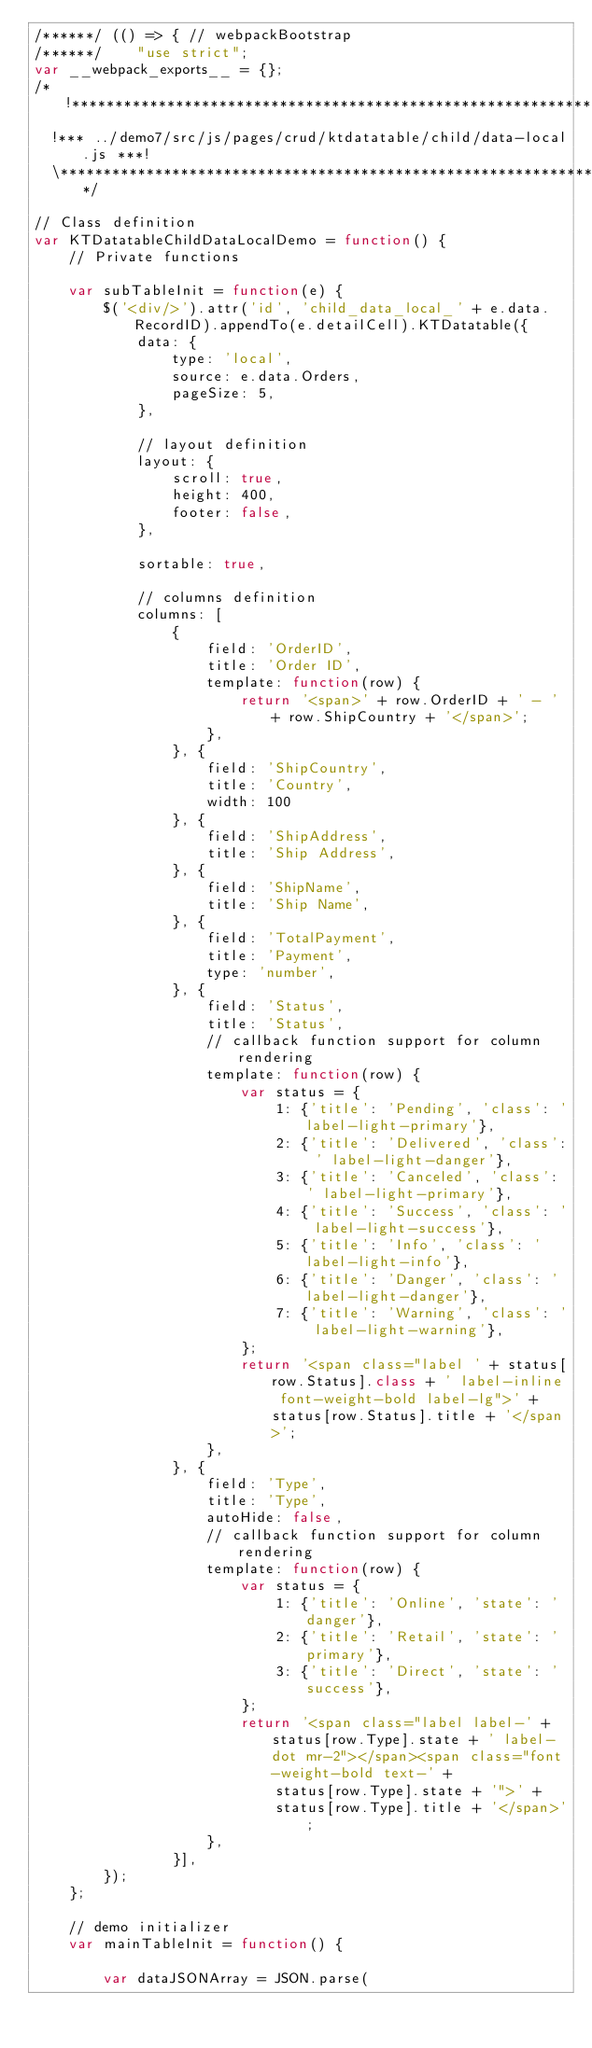<code> <loc_0><loc_0><loc_500><loc_500><_JavaScript_>/******/ (() => { // webpackBootstrap
/******/ 	"use strict";
var __webpack_exports__ = {};
/*!******************************************************************!*\
  !*** ../demo7/src/js/pages/crud/ktdatatable/child/data-local.js ***!
  \******************************************************************/

// Class definition
var KTDatatableChildDataLocalDemo = function() {
	// Private functions

	var subTableInit = function(e) {
		$('<div/>').attr('id', 'child_data_local_' + e.data.RecordID).appendTo(e.detailCell).KTDatatable({
			data: {
				type: 'local',
				source: e.data.Orders,
				pageSize: 5,
			},

			// layout definition
			layout: {
				scroll: true,
				height: 400,
				footer: false,
			},

			sortable: true,

			// columns definition
			columns: [
				{
					field: 'OrderID',
					title: 'Order ID',
					template: function(row) {
						return '<span>' + row.OrderID + ' - ' + row.ShipCountry + '</span>';
					},
				}, {
					field: 'ShipCountry',
					title: 'Country',
					width: 100
				}, {
					field: 'ShipAddress',
					title: 'Ship Address',
				}, {
					field: 'ShipName',
					title: 'Ship Name',
				}, {
					field: 'TotalPayment',
					title: 'Payment',
					type: 'number',
				}, {
					field: 'Status',
					title: 'Status',
					// callback function support for column rendering
					template: function(row) {
						var status = {
							1: {'title': 'Pending', 'class': 'label-light-primary'},
							2: {'title': 'Delivered', 'class': ' label-light-danger'},
							3: {'title': 'Canceled', 'class': ' label-light-primary'},
							4: {'title': 'Success', 'class': ' label-light-success'},
							5: {'title': 'Info', 'class': ' label-light-info'},
							6: {'title': 'Danger', 'class': ' label-light-danger'},
							7: {'title': 'Warning', 'class': ' label-light-warning'},
						};
						return '<span class="label ' + status[row.Status].class + ' label-inline font-weight-bold label-lg">' + status[row.Status].title + '</span>';
					},
				}, {
					field: 'Type',
					title: 'Type',
					autoHide: false,
					// callback function support for column rendering
					template: function(row) {
						var status = {
							1: {'title': 'Online', 'state': 'danger'},
							2: {'title': 'Retail', 'state': 'primary'},
							3: {'title': 'Direct', 'state': 'success'},
						};
						return '<span class="label label-' + status[row.Type].state + ' label-dot mr-2"></span><span class="font-weight-bold text-' +
							status[row.Type].state + '">' +
							status[row.Type].title + '</span>';
					},
				}],
		});
	};

	// demo initializer
	var mainTableInit = function() {

		var dataJSONArray = JSON.parse(</code> 